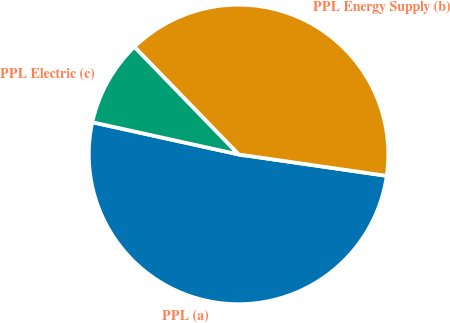<chart> <loc_0><loc_0><loc_500><loc_500><pie_chart><fcel>PPL (a)<fcel>PPL Energy Supply (b)<fcel>PPL Electric (c)<nl><fcel>51.16%<fcel>39.53%<fcel>9.3%<nl></chart> 